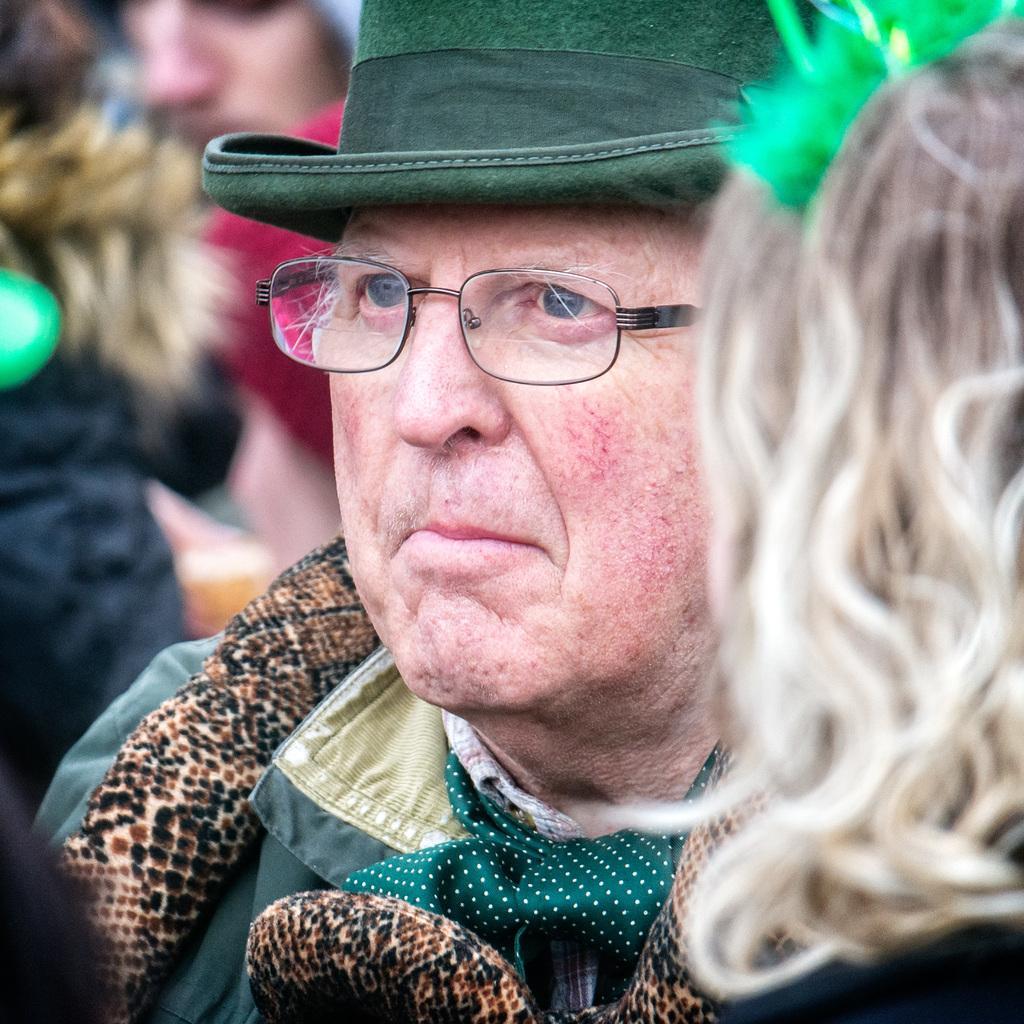In one or two sentences, can you explain what this image depicts? In this image we can see people. In the center we can see a man wearing a hat. 